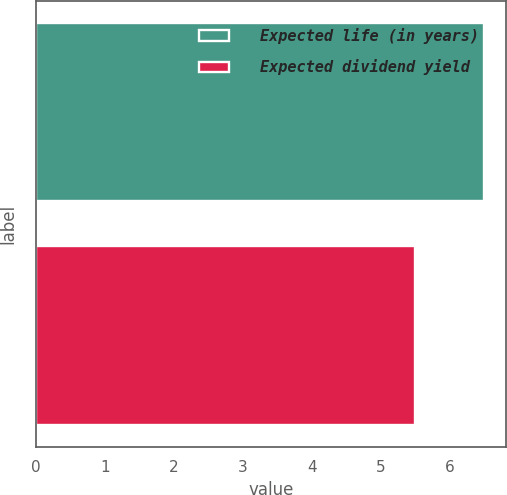Convert chart to OTSL. <chart><loc_0><loc_0><loc_500><loc_500><bar_chart><fcel>Expected life (in years)<fcel>Expected dividend yield<nl><fcel>6.5<fcel>5.5<nl></chart> 